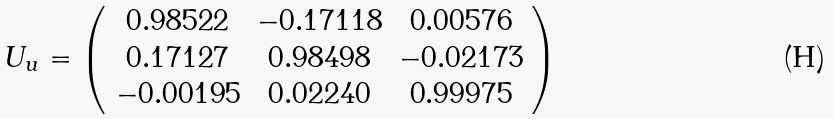Convert formula to latex. <formula><loc_0><loc_0><loc_500><loc_500>U _ { u } = \left ( \begin{array} { c c c } 0 . 9 8 5 2 2 & - 0 . 1 7 1 1 8 & 0 . 0 0 5 7 6 \\ 0 . 1 7 1 2 7 & 0 . 9 8 4 9 8 & - 0 . 0 2 1 7 3 \\ - 0 . 0 0 1 9 5 & 0 . 0 2 2 4 0 & 0 . 9 9 9 7 5 \end{array} \right )</formula> 